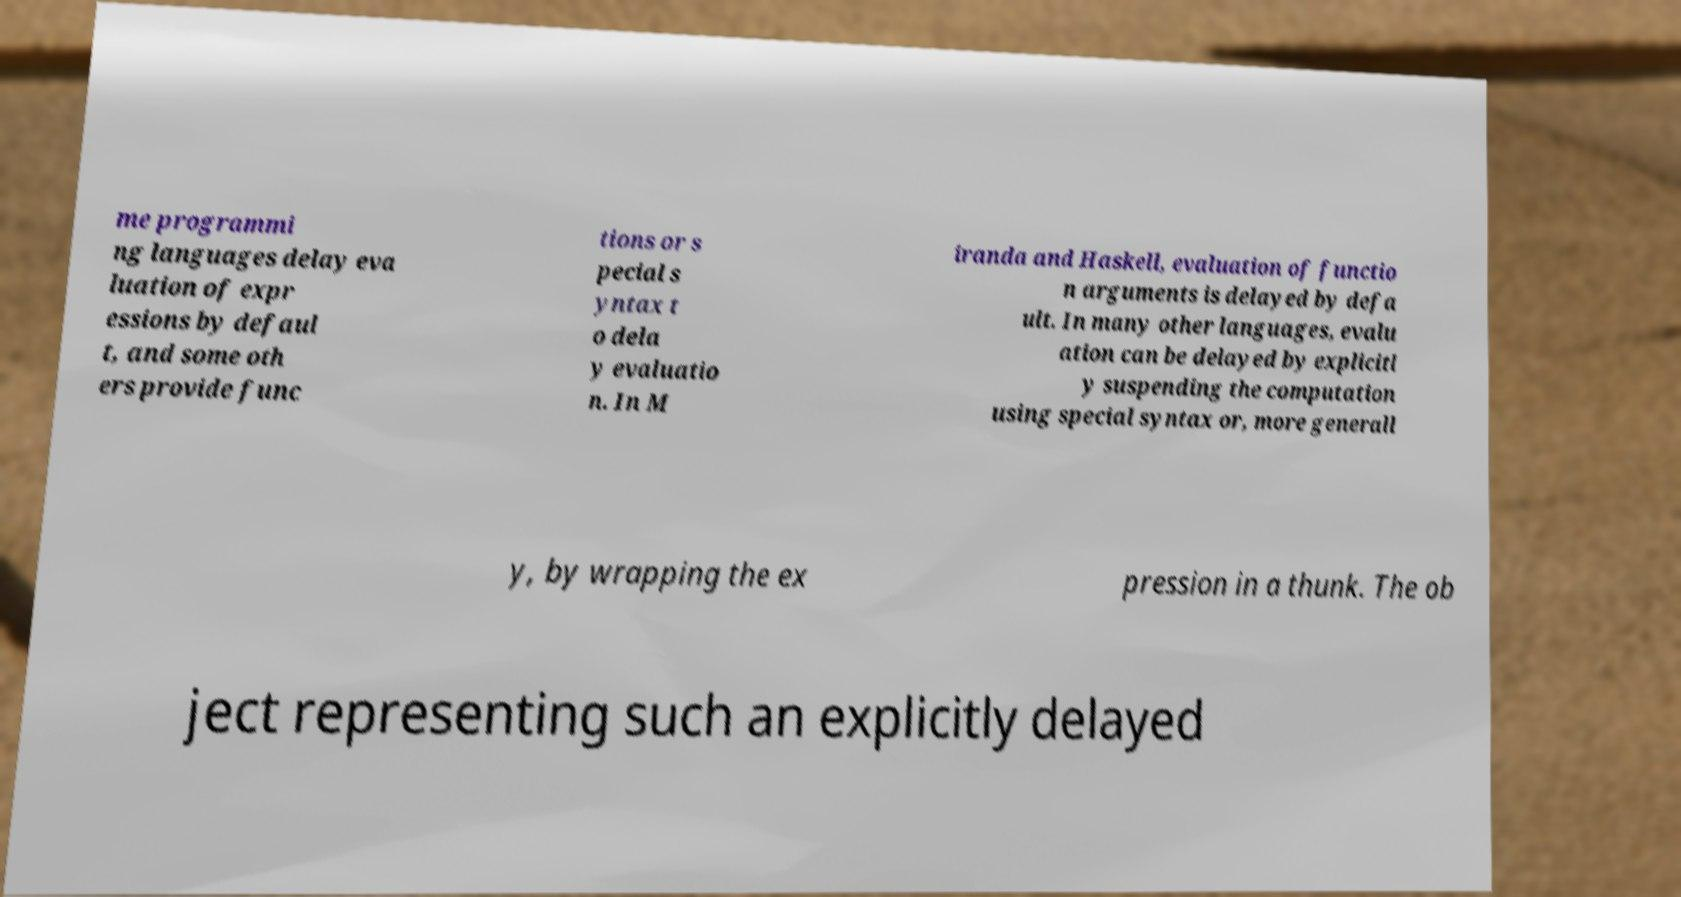Please read and relay the text visible in this image. What does it say? me programmi ng languages delay eva luation of expr essions by defaul t, and some oth ers provide func tions or s pecial s yntax t o dela y evaluatio n. In M iranda and Haskell, evaluation of functio n arguments is delayed by defa ult. In many other languages, evalu ation can be delayed by explicitl y suspending the computation using special syntax or, more generall y, by wrapping the ex pression in a thunk. The ob ject representing such an explicitly delayed 